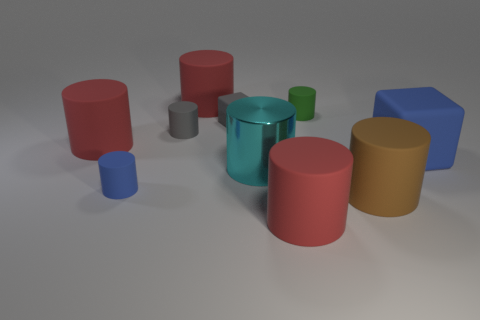Subtract all brown cubes. How many red cylinders are left? 3 Subtract all brown cylinders. How many cylinders are left? 7 Subtract all red cylinders. How many cylinders are left? 5 Subtract 1 gray cylinders. How many objects are left? 9 Subtract all cubes. How many objects are left? 8 Subtract all blue blocks. Subtract all red cylinders. How many blocks are left? 1 Subtract all tiny gray shiny cubes. Subtract all gray matte cubes. How many objects are left? 9 Add 4 tiny gray matte objects. How many tiny gray matte objects are left? 6 Add 6 tiny gray matte things. How many tiny gray matte things exist? 8 